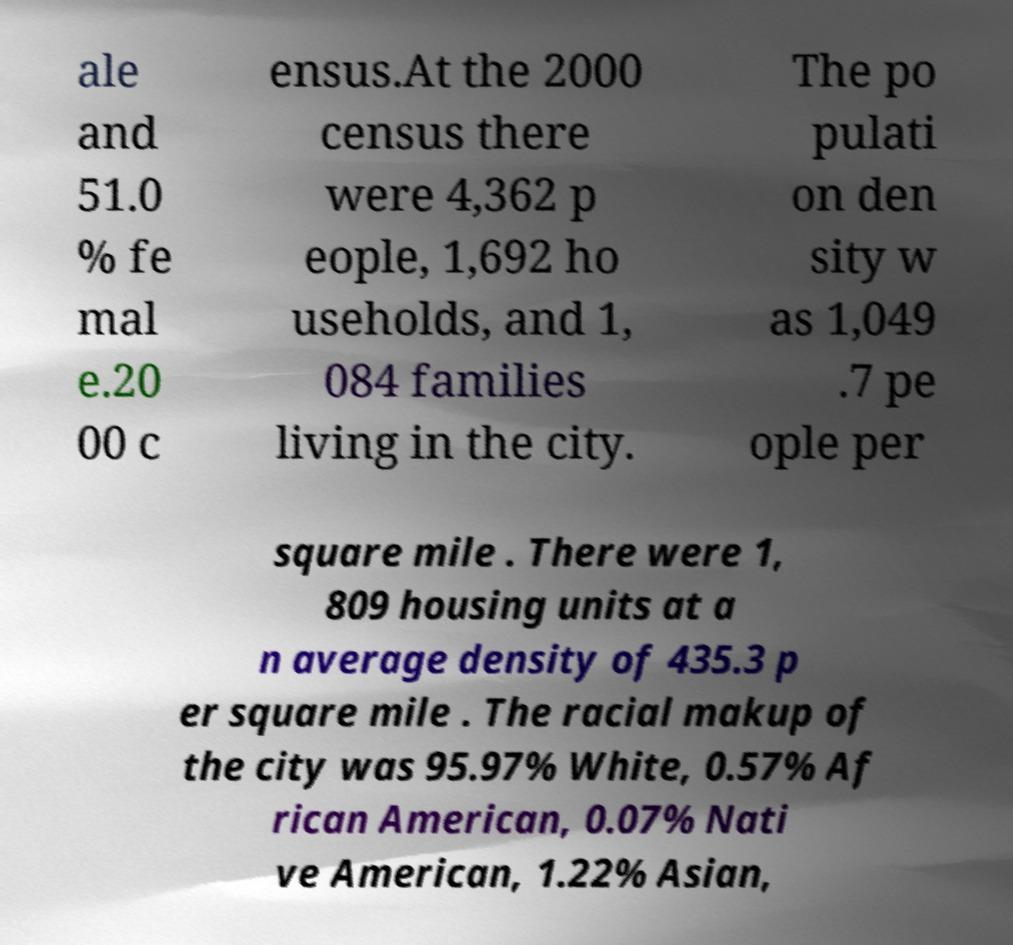Could you extract and type out the text from this image? ale and 51.0 % fe mal e.20 00 c ensus.At the 2000 census there were 4,362 p eople, 1,692 ho useholds, and 1, 084 families living in the city. The po pulati on den sity w as 1,049 .7 pe ople per square mile . There were 1, 809 housing units at a n average density of 435.3 p er square mile . The racial makup of the city was 95.97% White, 0.57% Af rican American, 0.07% Nati ve American, 1.22% Asian, 